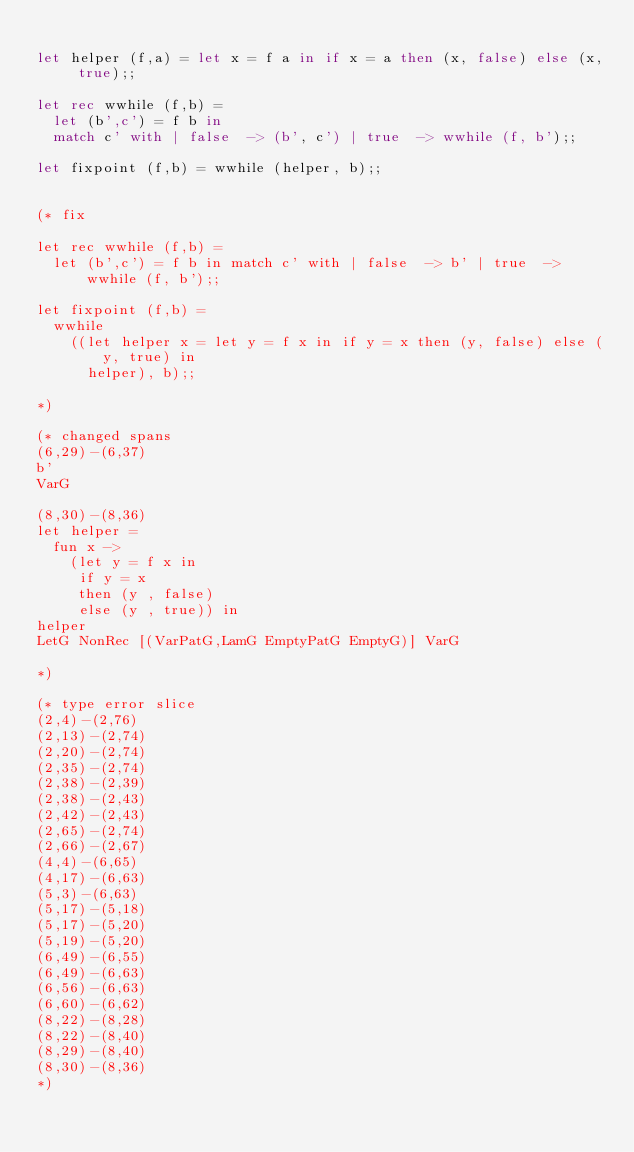Convert code to text. <code><loc_0><loc_0><loc_500><loc_500><_OCaml_>
let helper (f,a) = let x = f a in if x = a then (x, false) else (x, true);;

let rec wwhile (f,b) =
  let (b',c') = f b in
  match c' with | false  -> (b', c') | true  -> wwhile (f, b');;

let fixpoint (f,b) = wwhile (helper, b);;


(* fix

let rec wwhile (f,b) =
  let (b',c') = f b in match c' with | false  -> b' | true  -> wwhile (f, b');;

let fixpoint (f,b) =
  wwhile
    ((let helper x = let y = f x in if y = x then (y, false) else (y, true) in
      helper), b);;

*)

(* changed spans
(6,29)-(6,37)
b'
VarG

(8,30)-(8,36)
let helper =
  fun x ->
    (let y = f x in
     if y = x
     then (y , false)
     else (y , true)) in
helper
LetG NonRec [(VarPatG,LamG EmptyPatG EmptyG)] VarG

*)

(* type error slice
(2,4)-(2,76)
(2,13)-(2,74)
(2,20)-(2,74)
(2,35)-(2,74)
(2,38)-(2,39)
(2,38)-(2,43)
(2,42)-(2,43)
(2,65)-(2,74)
(2,66)-(2,67)
(4,4)-(6,65)
(4,17)-(6,63)
(5,3)-(6,63)
(5,17)-(5,18)
(5,17)-(5,20)
(5,19)-(5,20)
(6,49)-(6,55)
(6,49)-(6,63)
(6,56)-(6,63)
(6,60)-(6,62)
(8,22)-(8,28)
(8,22)-(8,40)
(8,29)-(8,40)
(8,30)-(8,36)
*)
</code> 